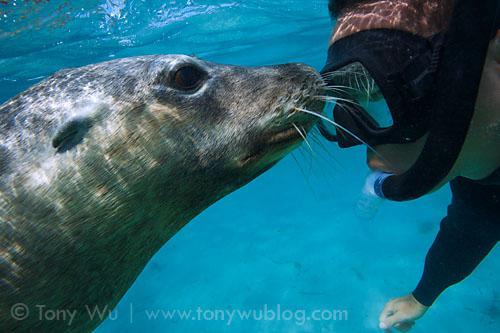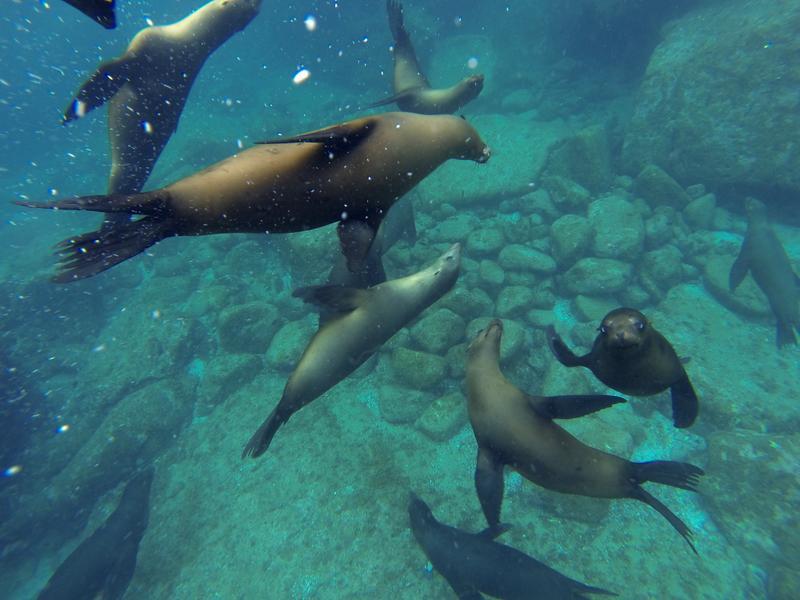The first image is the image on the left, the second image is the image on the right. Analyze the images presented: Is the assertion "An image of an otter underwater includes a scuba diver." valid? Answer yes or no. Yes. The first image is the image on the left, the second image is the image on the right. Considering the images on both sides, is "A diver is swimming near a sea animal." valid? Answer yes or no. Yes. 